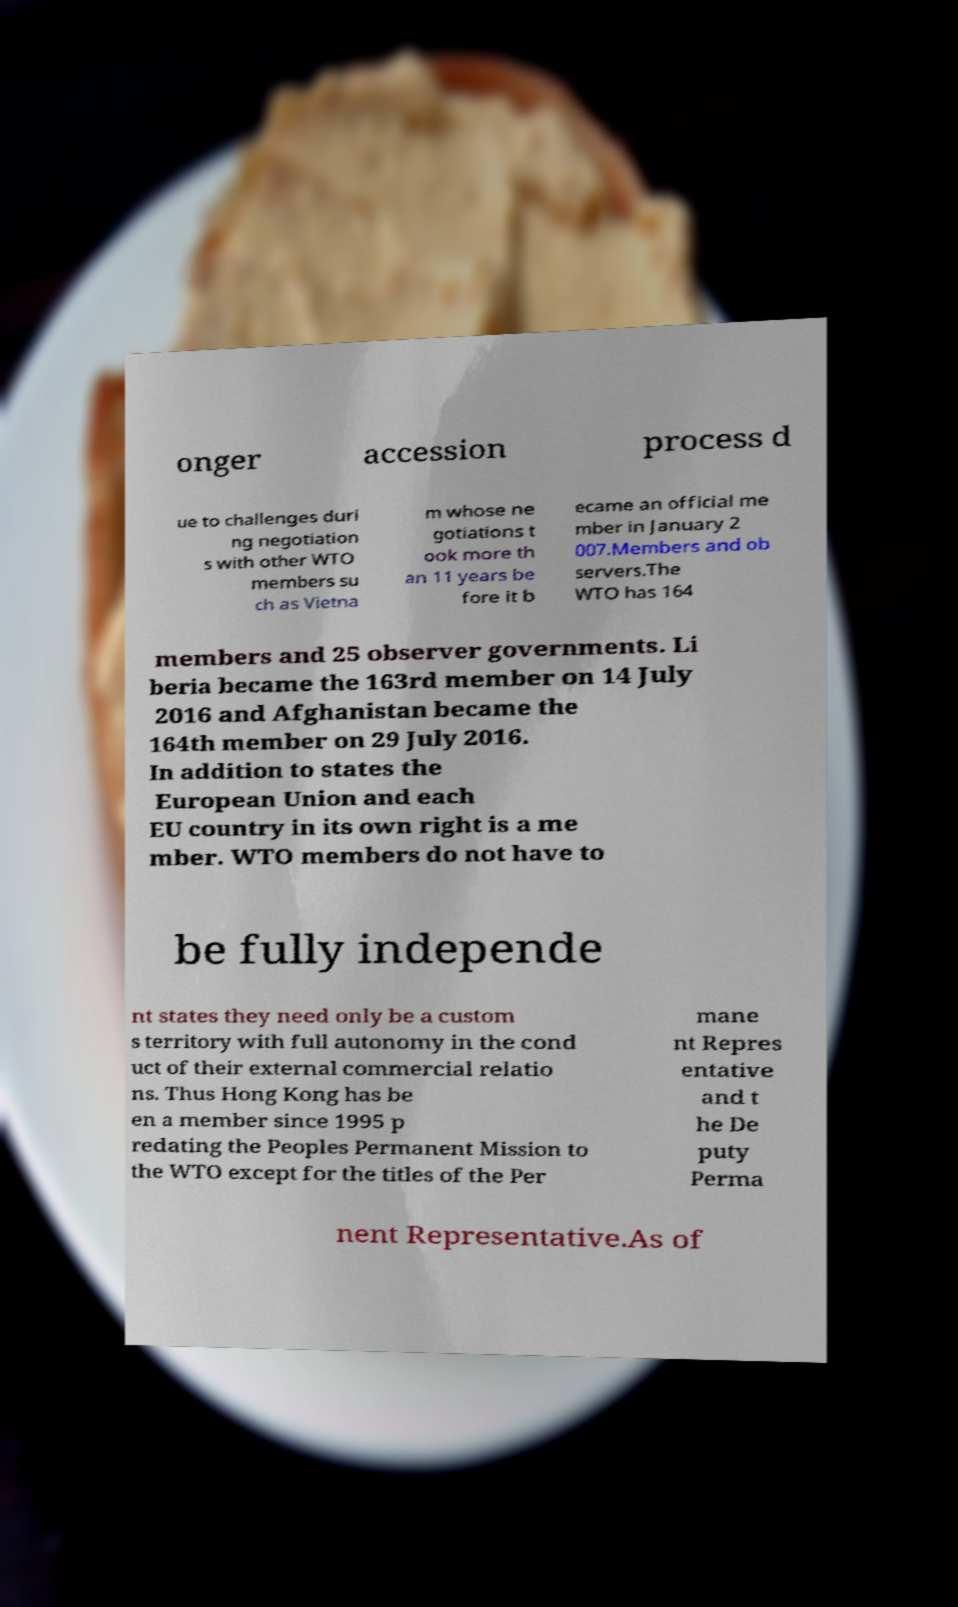Could you assist in decoding the text presented in this image and type it out clearly? onger accession process d ue to challenges duri ng negotiation s with other WTO members su ch as Vietna m whose ne gotiations t ook more th an 11 years be fore it b ecame an official me mber in January 2 007.Members and ob servers.The WTO has 164 members and 25 observer governments. Li beria became the 163rd member on 14 July 2016 and Afghanistan became the 164th member on 29 July 2016. In addition to states the European Union and each EU country in its own right is a me mber. WTO members do not have to be fully independe nt states they need only be a custom s territory with full autonomy in the cond uct of their external commercial relatio ns. Thus Hong Kong has be en a member since 1995 p redating the Peoples Permanent Mission to the WTO except for the titles of the Per mane nt Repres entative and t he De puty Perma nent Representative.As of 